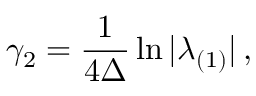Convert formula to latex. <formula><loc_0><loc_0><loc_500><loc_500>\gamma _ { 2 } = \frac { 1 } { 4 \Delta } \ln | \lambda _ { ( 1 ) } | \, ,</formula> 